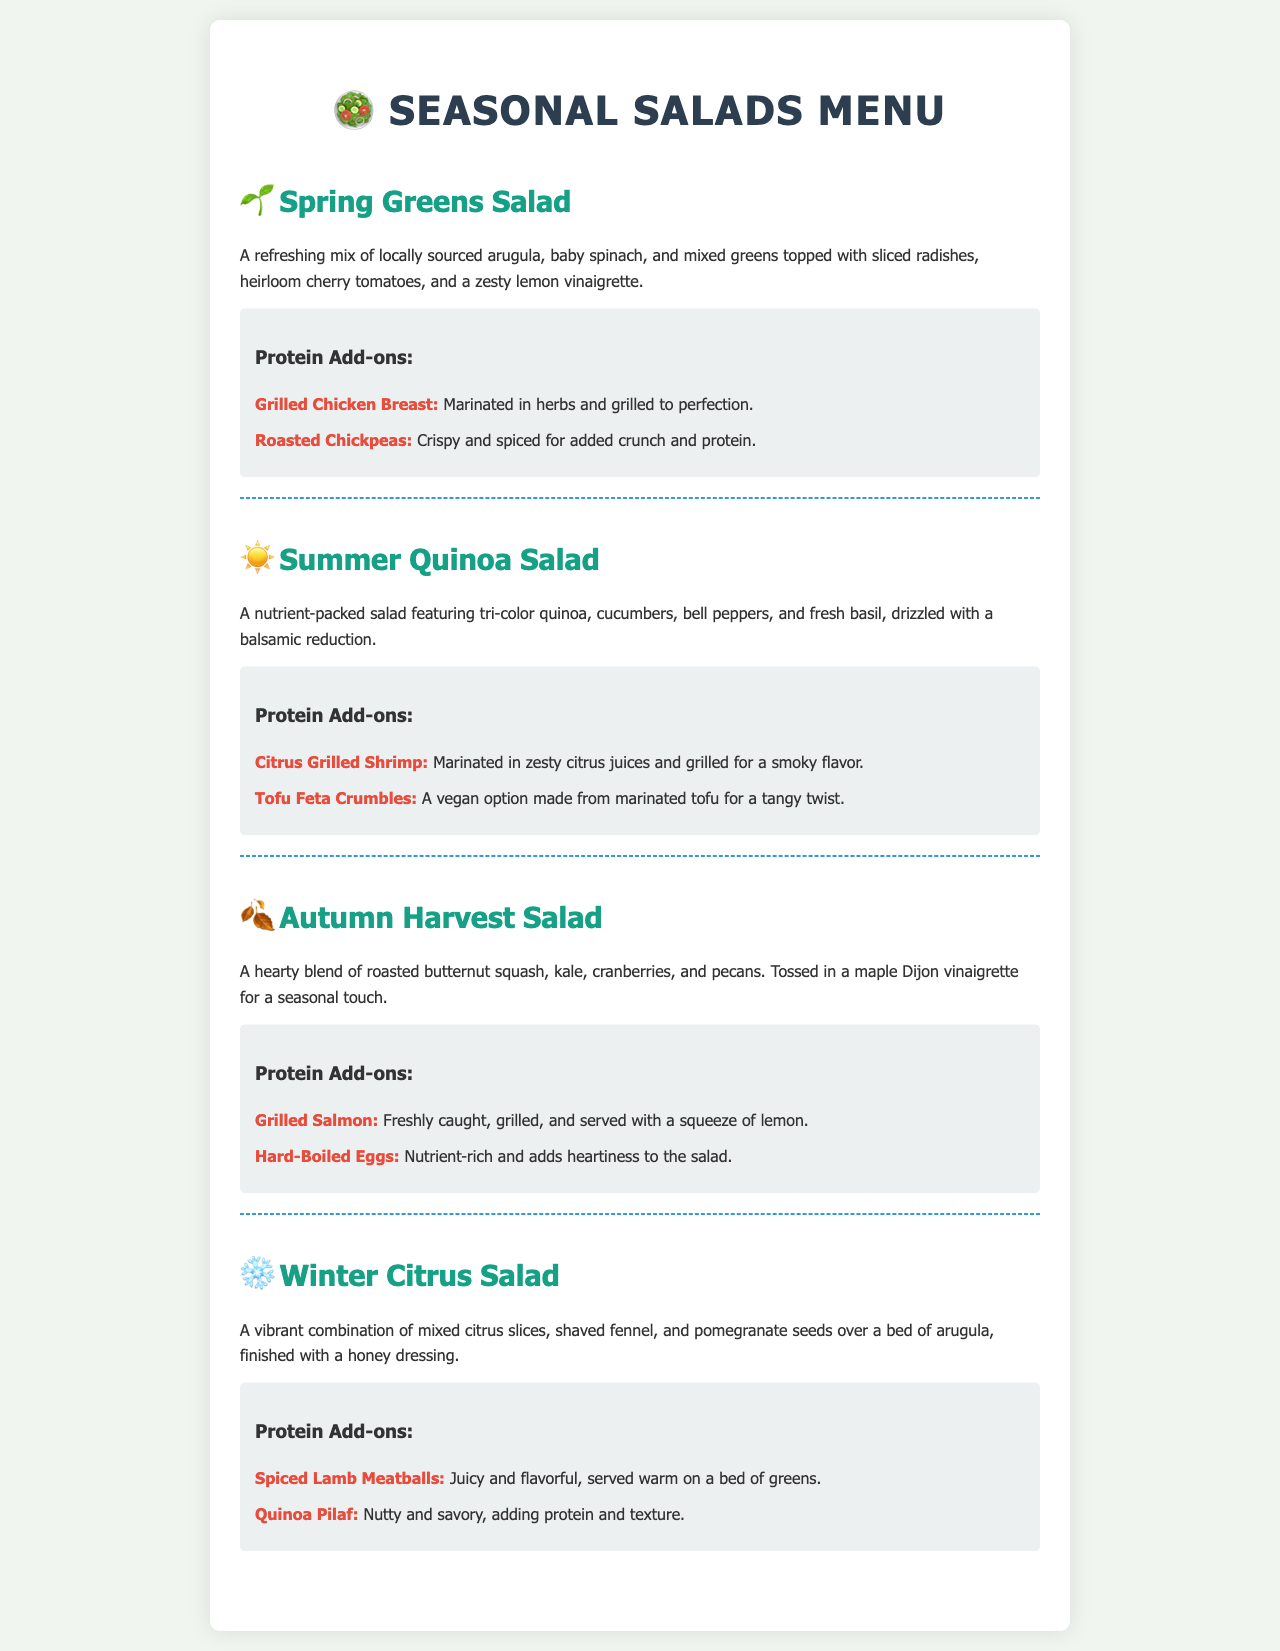What are the ingredients in the Spring Greens Salad? The ingredients of the Spring Greens Salad are locally sourced arugula, baby spinach, mixed greens, sliced radishes, heirloom cherry tomatoes, and a zesty lemon vinaigrette.
Answer: Arugula, baby spinach, mixed greens, sliced radishes, heirloom cherry tomatoes, lemon vinaigrette How many protein add-ons are available for the Autumn Harvest Salad? The Autumn Harvest Salad has two protein add-ons listed: Grilled Salmon and Hard-Boiled Eggs.
Answer: 2 Which salad features tri-color quinoa? The salad that features tri-color quinoa is the Summer Quinoa Salad.
Answer: Summer Quinoa Salad What dressing is used in the Winter Citrus Salad? The dressing used in the Winter Citrus Salad is a honey dressing.
Answer: Honey dressing What type of beans are used as a protein option in the Spring Greens Salad? The protein option in the Spring Greens Salad uses roasted chickpeas.
Answer: Roasted Chickpeas Which salad includes pomegranate seeds? The salad that includes pomegranate seeds is the Winter Citrus Salad.
Answer: Winter Citrus Salad What is the main protein option for the Summer Quinoa Salad? The main protein option for the Summer Quinoa Salad is Citrus Grilled Shrimp.
Answer: Citrus Grilled Shrimp What is the theme of the salads based on the seasons? The theme of the salads is based on seasonal ingredients such as spring, summer, autumn, and winter.
Answer: Seasonal Ingredients Which salad has a maple Dijon vinaigrette? The salad that has a maple Dijon vinaigrette is the Autumn Harvest Salad.
Answer: Autumn Harvest Salad 